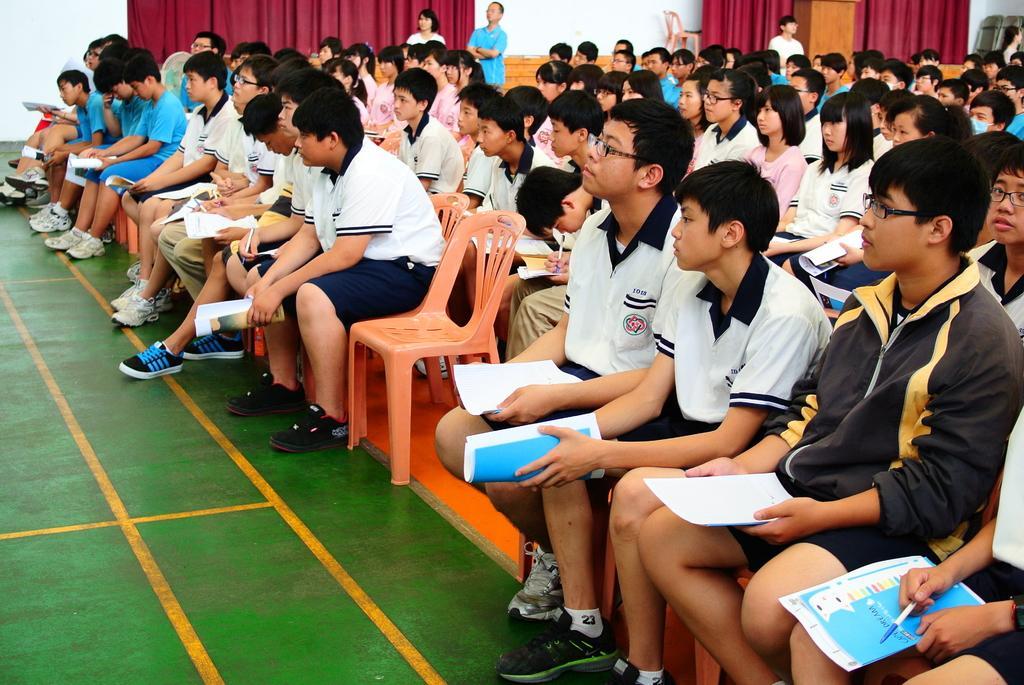In one or two sentences, can you explain what this image depicts? In this image we can see there are a few people sitting on their chairs and they are holding papers and pen in their hand and a few are standing. In the background there are curtains hanging on the wall. 